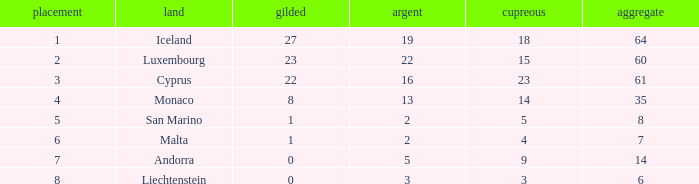How many bronzes for Iceland with over 2 silvers? 18.0. 